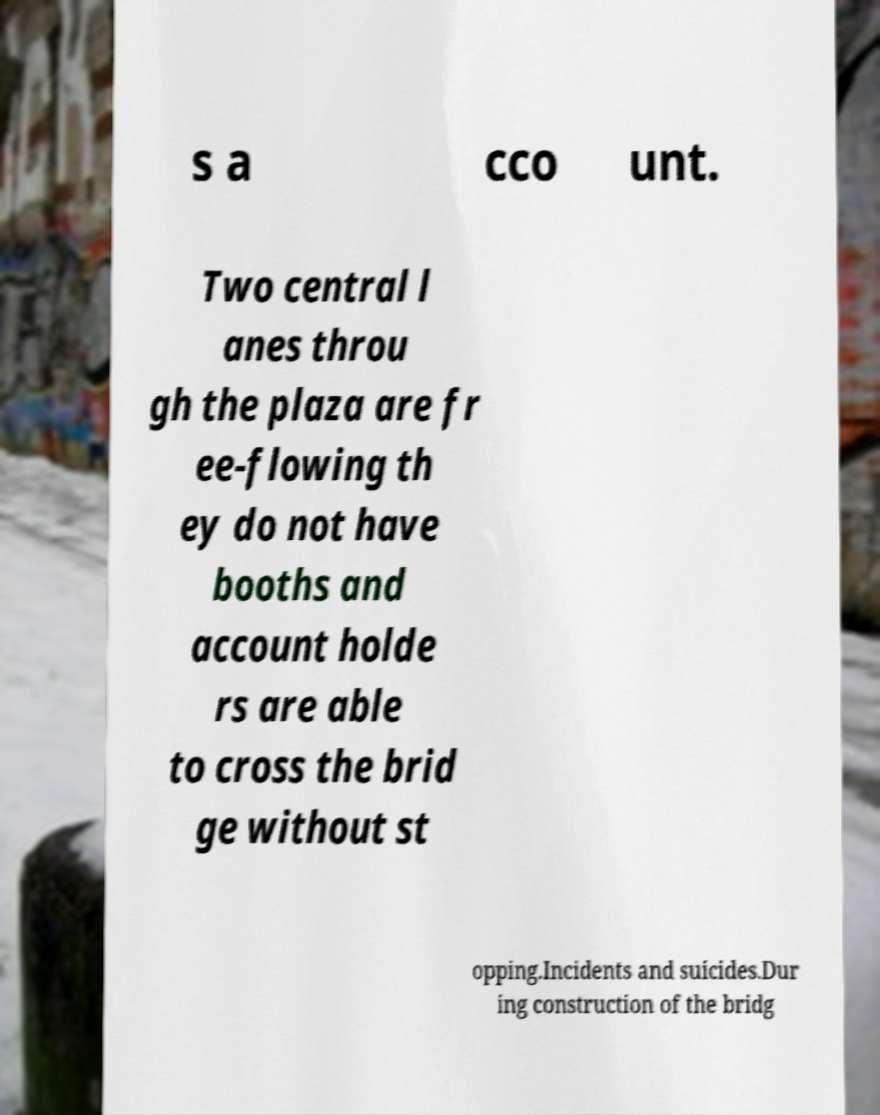Please identify and transcribe the text found in this image. s a cco unt. Two central l anes throu gh the plaza are fr ee-flowing th ey do not have booths and account holde rs are able to cross the brid ge without st opping.Incidents and suicides.Dur ing construction of the bridg 